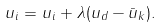<formula> <loc_0><loc_0><loc_500><loc_500>u _ { i } = u _ { i } + \lambda ( u _ { d } - \bar { u } _ { k } ) .</formula> 